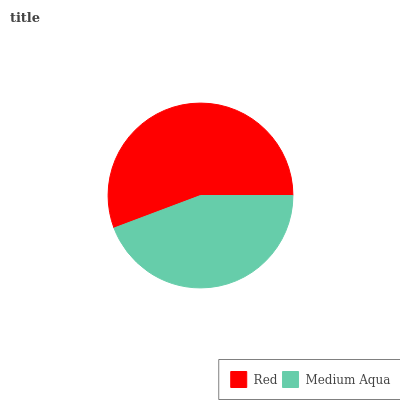Is Medium Aqua the minimum?
Answer yes or no. Yes. Is Red the maximum?
Answer yes or no. Yes. Is Medium Aqua the maximum?
Answer yes or no. No. Is Red greater than Medium Aqua?
Answer yes or no. Yes. Is Medium Aqua less than Red?
Answer yes or no. Yes. Is Medium Aqua greater than Red?
Answer yes or no. No. Is Red less than Medium Aqua?
Answer yes or no. No. Is Red the high median?
Answer yes or no. Yes. Is Medium Aqua the low median?
Answer yes or no. Yes. Is Medium Aqua the high median?
Answer yes or no. No. Is Red the low median?
Answer yes or no. No. 